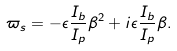<formula> <loc_0><loc_0><loc_500><loc_500>\varpi _ { s } = - \epsilon \frac { I _ { b } } { I _ { p } } \beta ^ { 2 } + i \epsilon \frac { I _ { b } } { I _ { p } } \beta .</formula> 